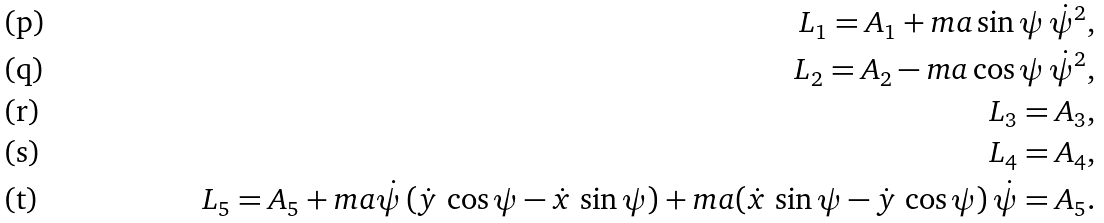Convert formula to latex. <formula><loc_0><loc_0><loc_500><loc_500>L _ { 1 } = A _ { 1 } + m a \sin \psi \, \dot { \psi } ^ { 2 } , \\ L _ { 2 } = A _ { 2 } - m a \cos \psi \, \dot { \psi } ^ { 2 } , \\ L _ { 3 } = A _ { 3 } , \\ L _ { 4 } = A _ { 4 } , \\ L _ { 5 } = A _ { 5 } + m a \dot { \psi } \, ( \dot { y } \, \cos \psi - \dot { x } \, \sin \psi ) + m a ( \dot { x } \, \sin \psi - \dot { y } \, \cos \psi ) \, \dot { \psi } = A _ { 5 } .</formula> 